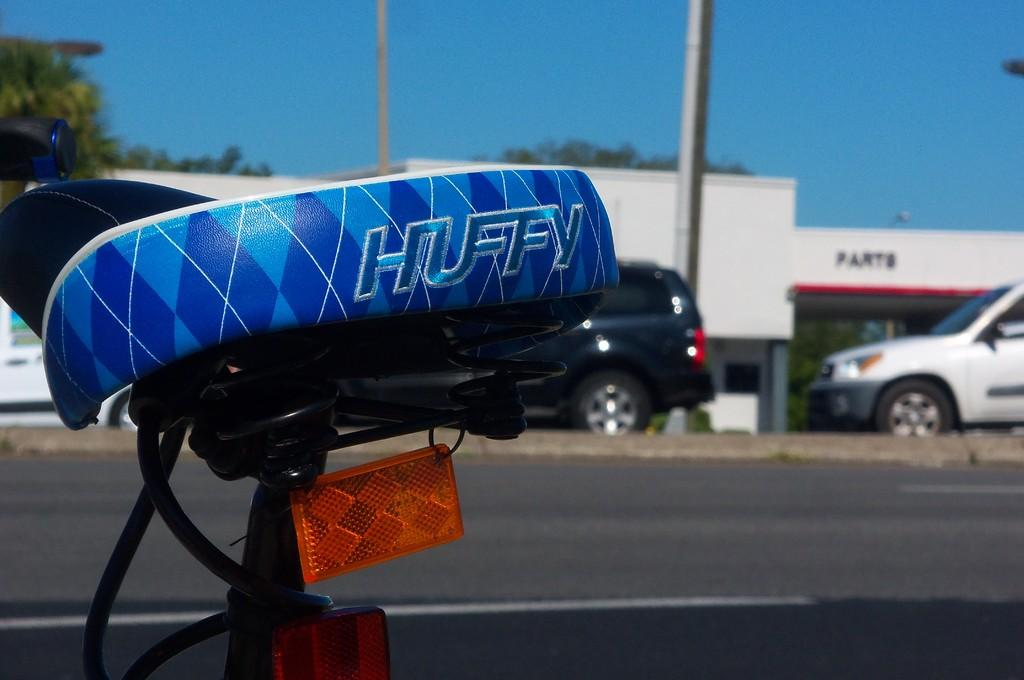What object is the main focus of the image? The main focus of the image is the seat of a bicycle. What can be seen in the foreground of the image? There is a road in the image. What is located behind the road in the image? Cars are parked behind the road. What is visible in the background of the image? There is a shop and trees in the background of the image, and the sky is blue. What type of trousers is the shop owner wearing in the image? There is no shop owner visible in the image, and therefore no trousers can be observed. 